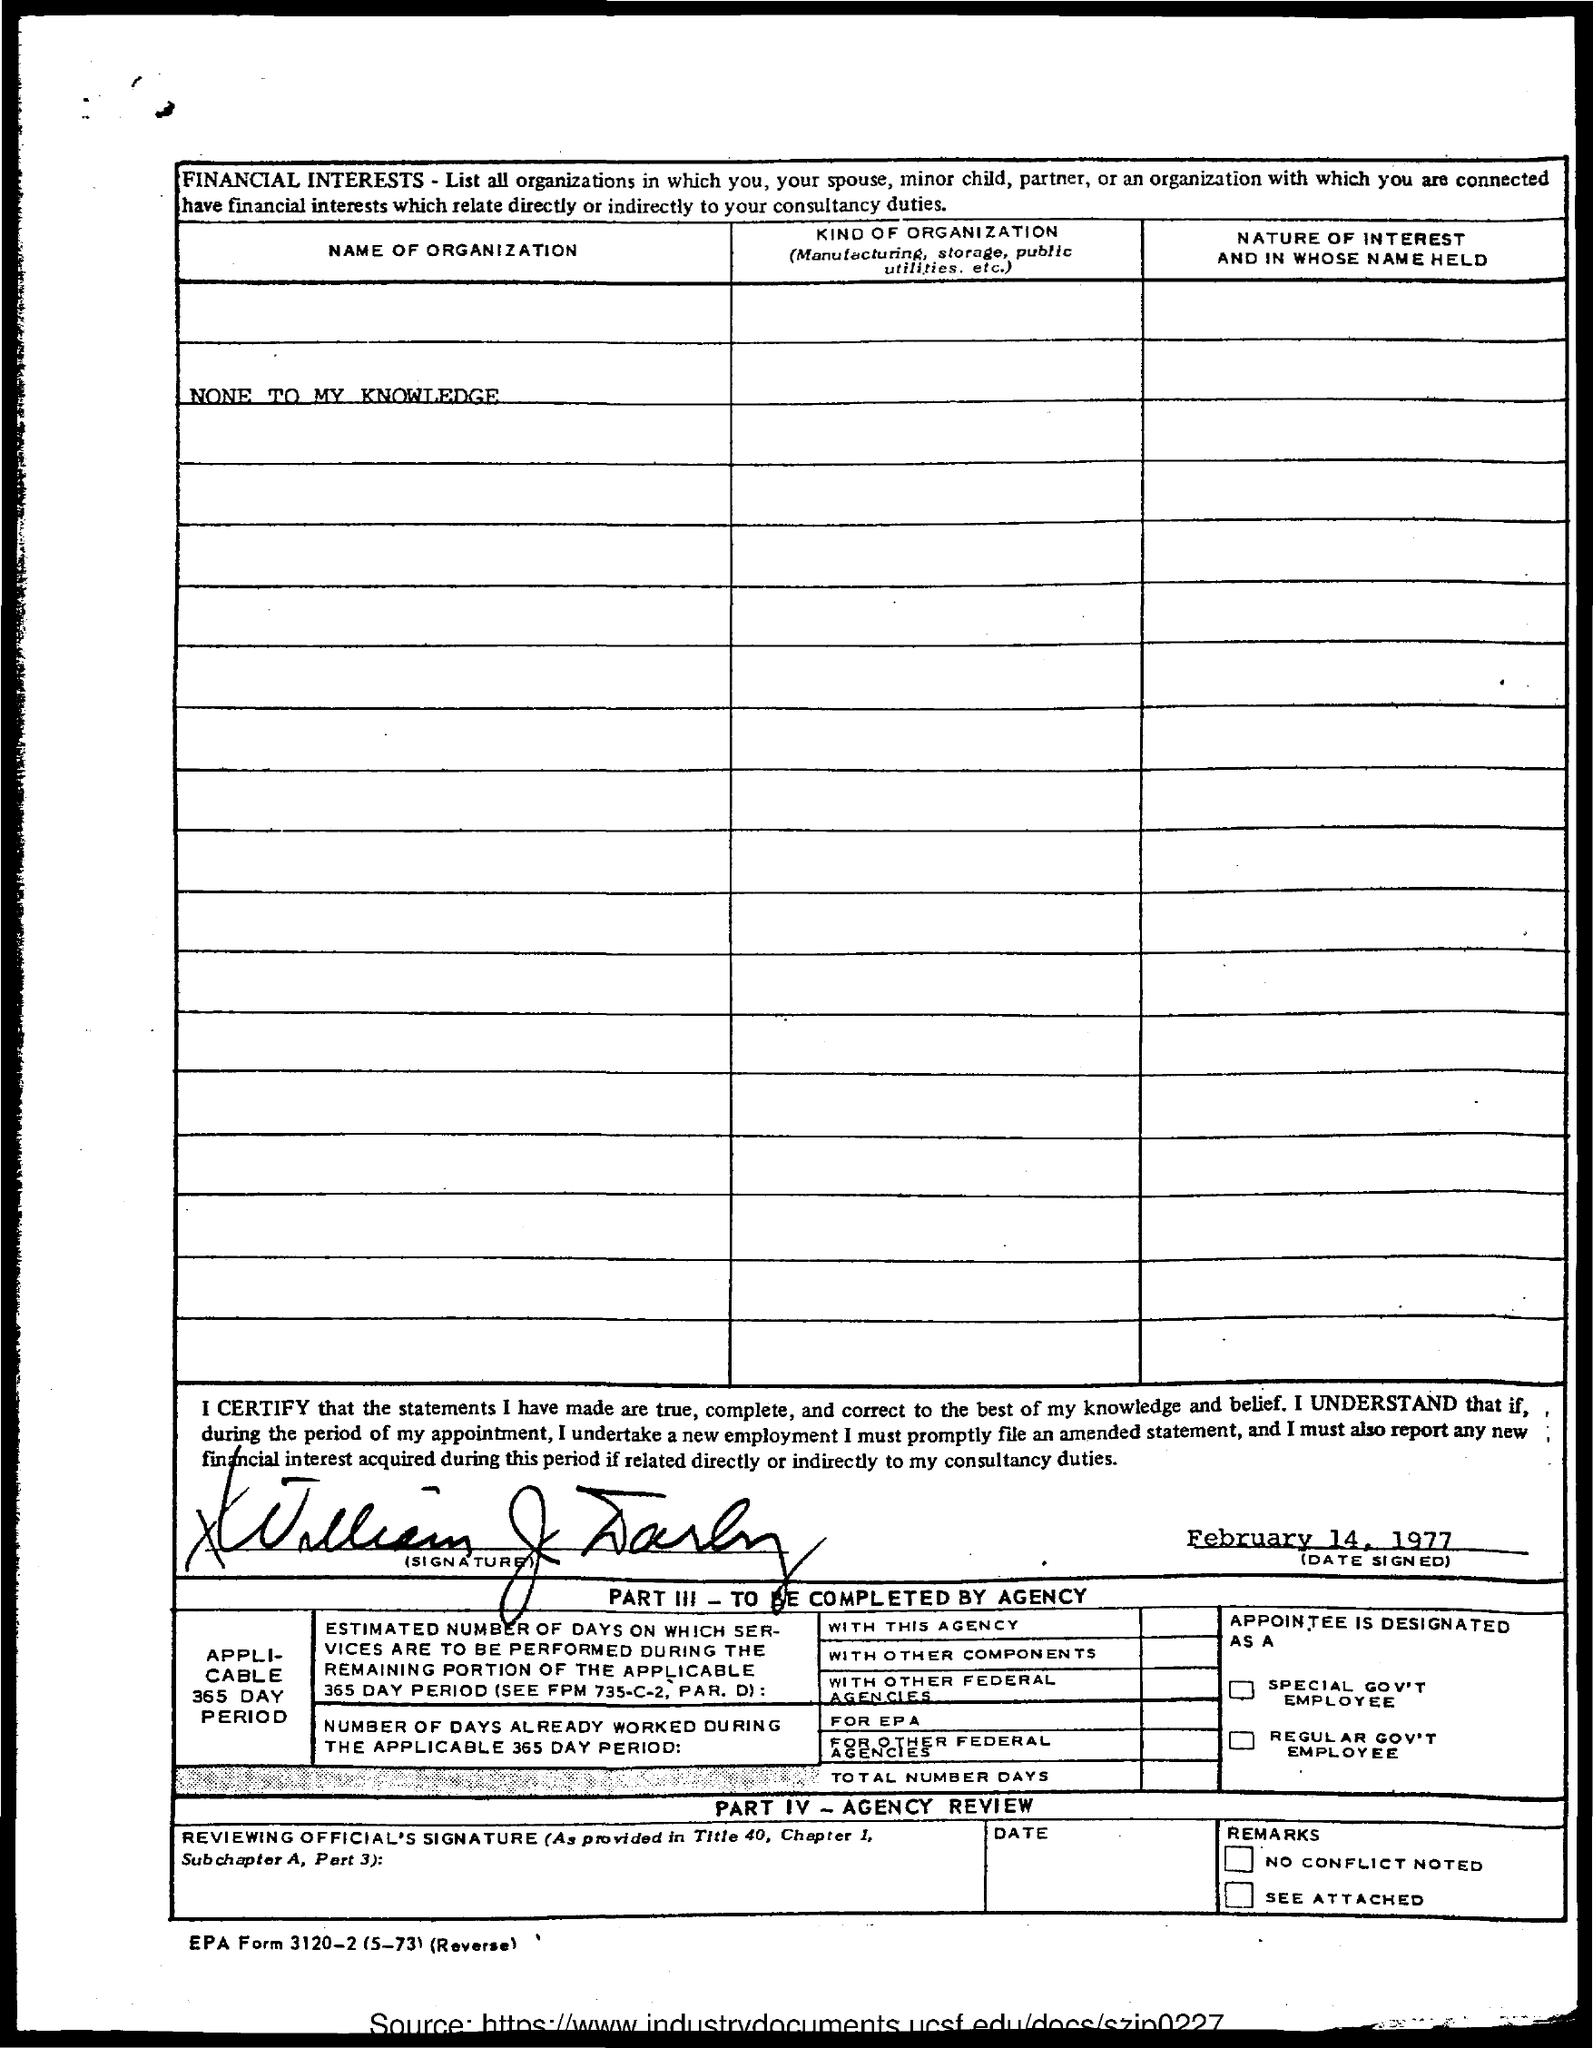Who signed the document?
Make the answer very short. WILLIAM J. DARBY. What is the date of the signing?
Keep it short and to the point. FEBRUARY 14, 1977. What is the title of the first column?
Your response must be concise. NAME OF ORGANIZATION. 